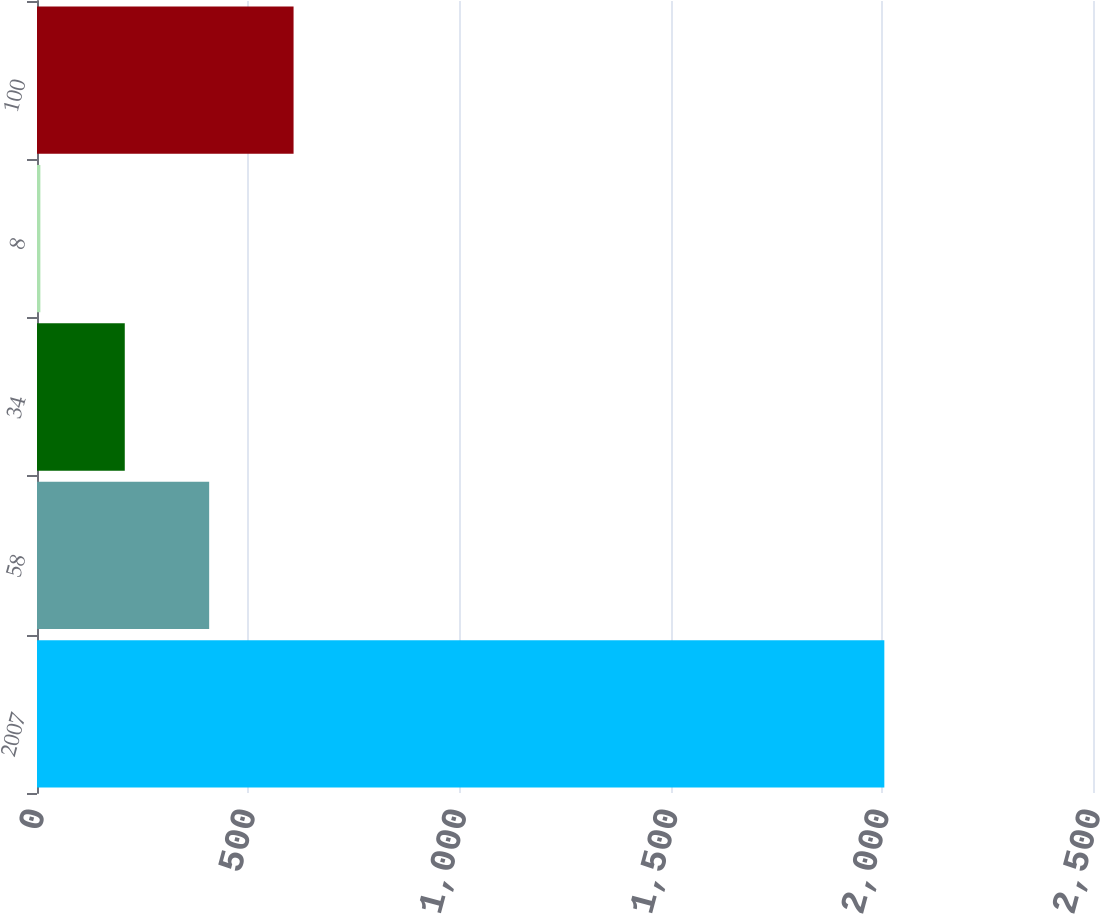Convert chart. <chart><loc_0><loc_0><loc_500><loc_500><bar_chart><fcel>2007<fcel>58<fcel>34<fcel>8<fcel>100<nl><fcel>2006<fcel>407.6<fcel>207.8<fcel>8<fcel>607.4<nl></chart> 